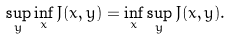Convert formula to latex. <formula><loc_0><loc_0><loc_500><loc_500>\sup _ { y } \inf _ { x } J ( x , y ) = \inf _ { x } \sup _ { y } J ( x , y ) .</formula> 